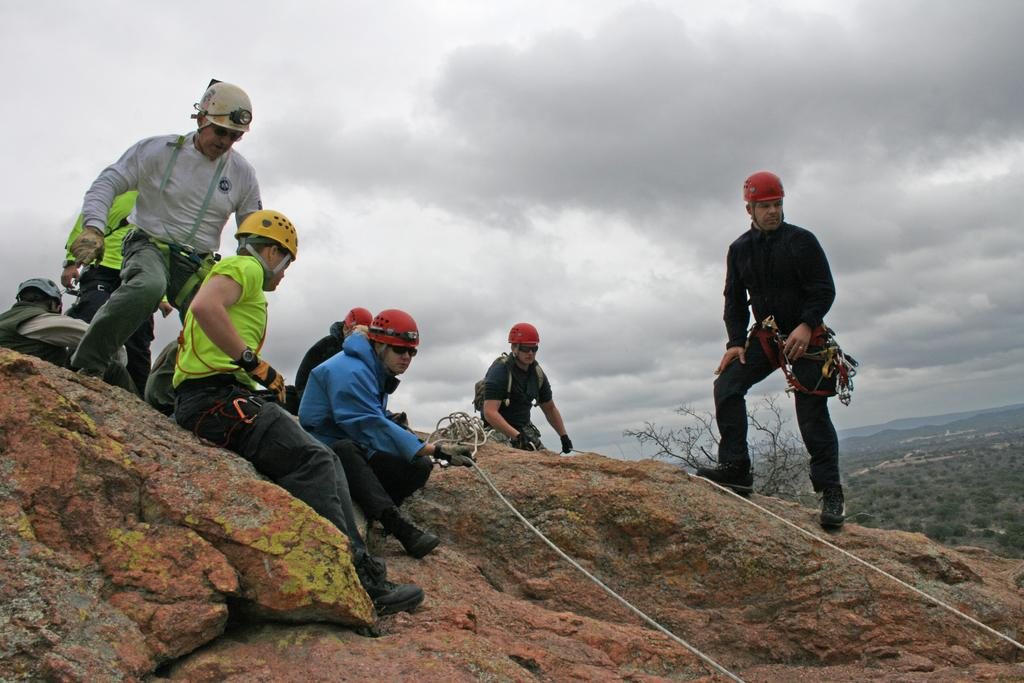How many people are in the image? There are people in the image, but the exact number is not specified. What can be seen in the image besides the people? There are ropes and a rock surface visible in the image. What is the weather like in the image? The sky is cloudy in the image, suggesting a potentially overcast or rainy day. What is one person doing in the image? One person is holding a rope. What else is near the person holding the rope? Near the person holding the rope, there are objects visible in the image. What statement does the person holding the rope make in the image? There is no information about any statements made by the person holding the rope in the image. What type of feeling does the hand holding the rope convey in the image? The image does not provide information about the emotions or feelings conveyed by the person holding the rope. 